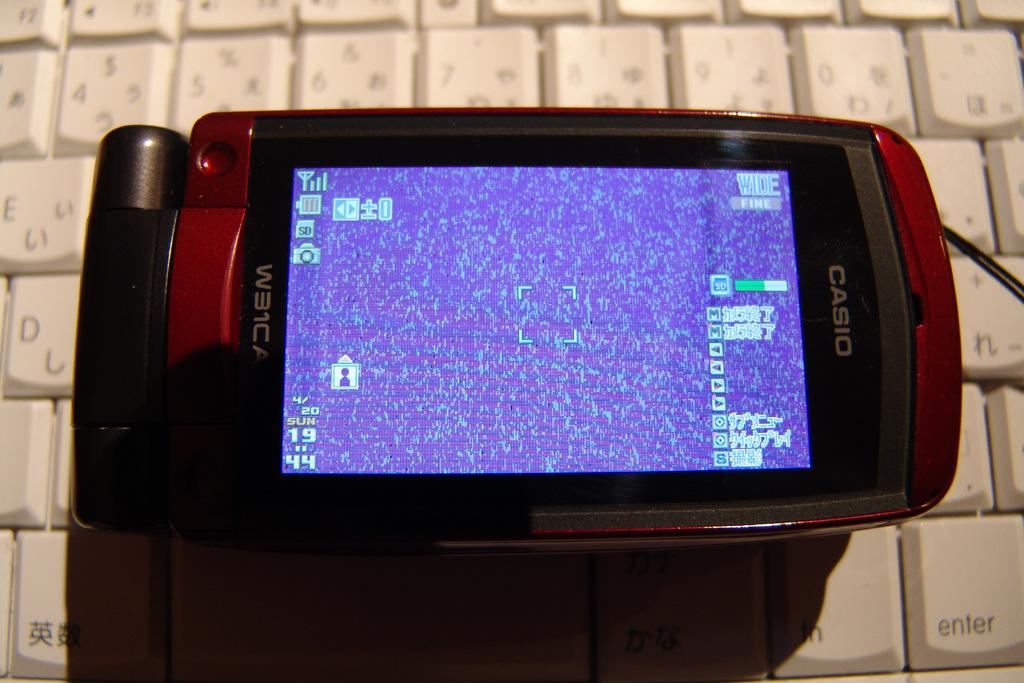Provide a one-sentence caption for the provided image. A Casio brand phone has a model number of W31CA. 